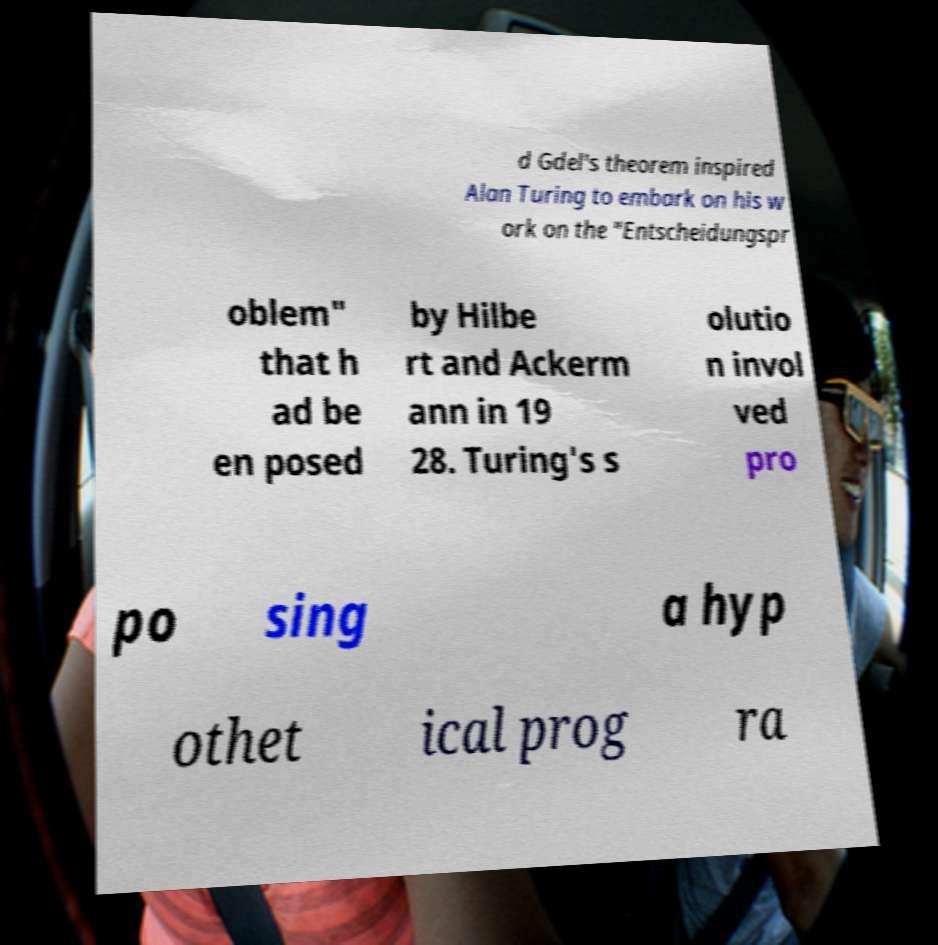There's text embedded in this image that I need extracted. Can you transcribe it verbatim? d Gdel's theorem inspired Alan Turing to embark on his w ork on the "Entscheidungspr oblem" that h ad be en posed by Hilbe rt and Ackerm ann in 19 28. Turing's s olutio n invol ved pro po sing a hyp othet ical prog ra 